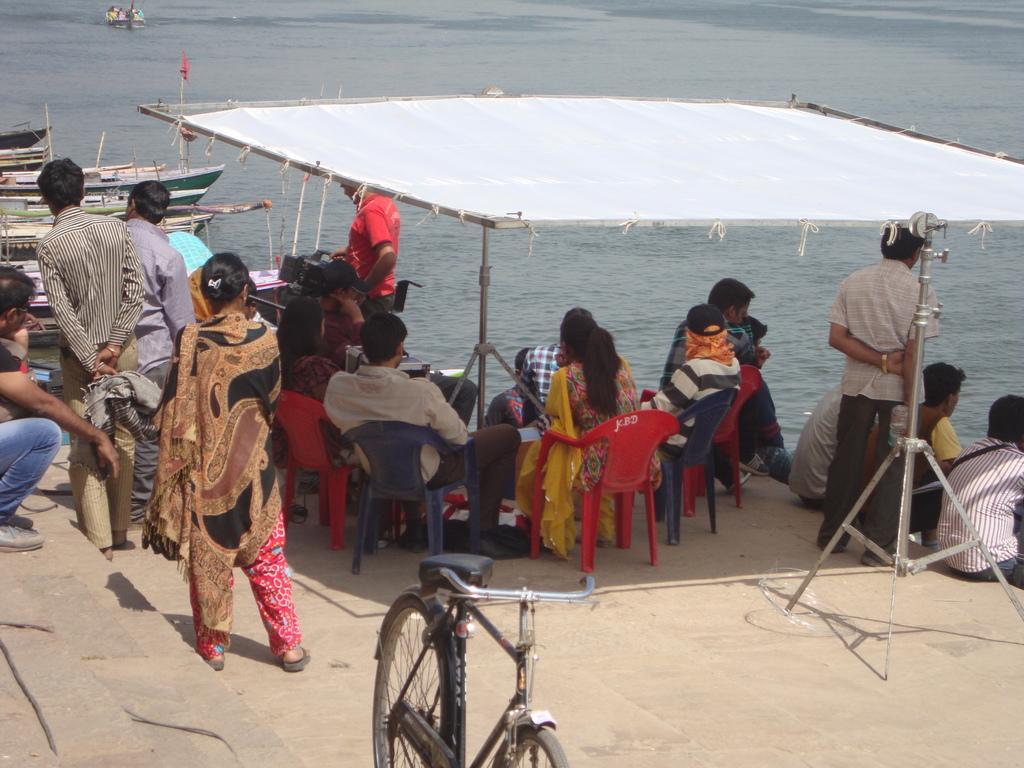What are the people in the image doing? The people in the image are sitting on chairs. What structure can be seen in the image? There is a shed in the image. What type of vehicles are present in the image? There are boats in the image. What natural element is visible in the image? There is water visible in the image. What type of minister is present in the image? There is no minister present in the image. What is the source of power for the boats in the image? The image does not provide information about the source of power for the boats. 